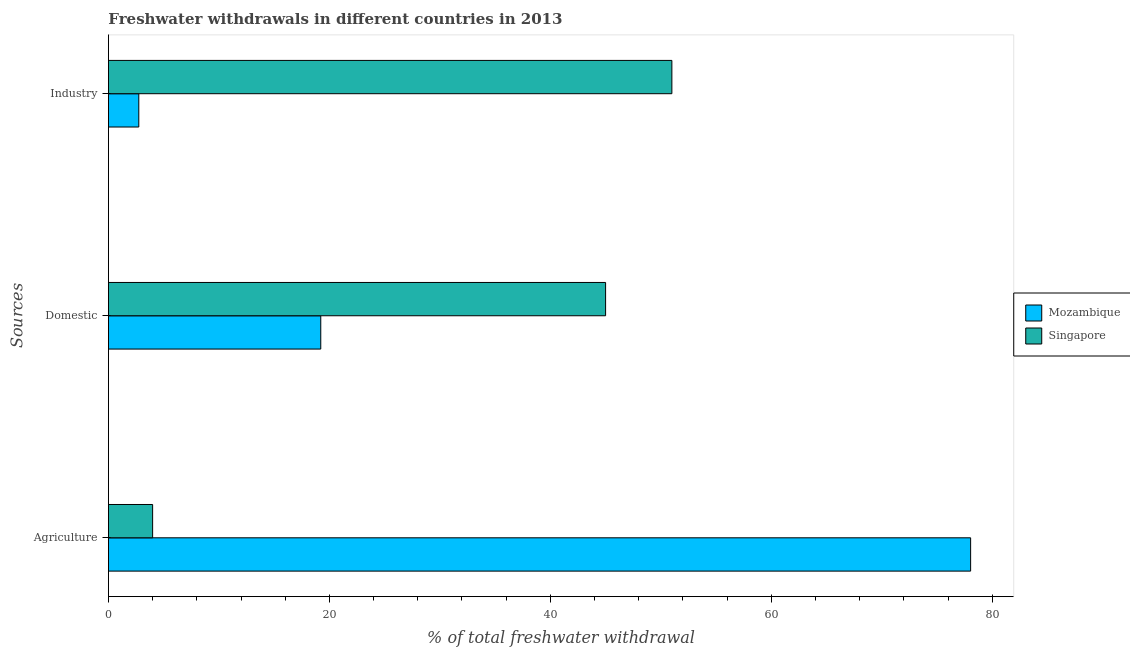How many different coloured bars are there?
Your answer should be very brief. 2. How many groups of bars are there?
Your response must be concise. 3. Are the number of bars per tick equal to the number of legend labels?
Your response must be concise. Yes. Are the number of bars on each tick of the Y-axis equal?
Make the answer very short. Yes. How many bars are there on the 1st tick from the top?
Ensure brevity in your answer.  2. How many bars are there on the 3rd tick from the bottom?
Your answer should be compact. 2. What is the label of the 1st group of bars from the top?
Your response must be concise. Industry. What is the percentage of freshwater withdrawal for agriculture in Mozambique?
Provide a short and direct response. 78.04. Across all countries, what is the maximum percentage of freshwater withdrawal for agriculture?
Offer a terse response. 78.04. In which country was the percentage of freshwater withdrawal for domestic purposes maximum?
Provide a short and direct response. Singapore. In which country was the percentage of freshwater withdrawal for domestic purposes minimum?
Keep it short and to the point. Mozambique. What is the total percentage of freshwater withdrawal for agriculture in the graph?
Your answer should be very brief. 82.04. What is the difference between the percentage of freshwater withdrawal for industry in Singapore and that in Mozambique?
Offer a very short reply. 48.25. What is the difference between the percentage of freshwater withdrawal for agriculture in Singapore and the percentage of freshwater withdrawal for domestic purposes in Mozambique?
Keep it short and to the point. -15.22. What is the average percentage of freshwater withdrawal for industry per country?
Provide a short and direct response. 26.87. What is the difference between the percentage of freshwater withdrawal for agriculture and percentage of freshwater withdrawal for domestic purposes in Singapore?
Give a very brief answer. -41. In how many countries, is the percentage of freshwater withdrawal for industry greater than 16 %?
Make the answer very short. 1. What is the ratio of the percentage of freshwater withdrawal for domestic purposes in Mozambique to that in Singapore?
Make the answer very short. 0.43. Is the percentage of freshwater withdrawal for agriculture in Mozambique less than that in Singapore?
Your answer should be compact. No. What is the difference between the highest and the second highest percentage of freshwater withdrawal for domestic purposes?
Your answer should be compact. 25.78. What is the difference between the highest and the lowest percentage of freshwater withdrawal for industry?
Provide a short and direct response. 48.25. In how many countries, is the percentage of freshwater withdrawal for domestic purposes greater than the average percentage of freshwater withdrawal for domestic purposes taken over all countries?
Your answer should be very brief. 1. What does the 2nd bar from the top in Agriculture represents?
Offer a terse response. Mozambique. What does the 2nd bar from the bottom in Agriculture represents?
Offer a very short reply. Singapore. Is it the case that in every country, the sum of the percentage of freshwater withdrawal for agriculture and percentage of freshwater withdrawal for domestic purposes is greater than the percentage of freshwater withdrawal for industry?
Offer a terse response. No. How many legend labels are there?
Your response must be concise. 2. What is the title of the graph?
Provide a short and direct response. Freshwater withdrawals in different countries in 2013. What is the label or title of the X-axis?
Your response must be concise. % of total freshwater withdrawal. What is the label or title of the Y-axis?
Provide a short and direct response. Sources. What is the % of total freshwater withdrawal of Mozambique in Agriculture?
Make the answer very short. 78.04. What is the % of total freshwater withdrawal of Mozambique in Domestic?
Offer a terse response. 19.22. What is the % of total freshwater withdrawal in Mozambique in Industry?
Your answer should be very brief. 2.75. What is the % of total freshwater withdrawal of Singapore in Industry?
Make the answer very short. 51. Across all Sources, what is the maximum % of total freshwater withdrawal of Mozambique?
Your response must be concise. 78.04. Across all Sources, what is the maximum % of total freshwater withdrawal in Singapore?
Your answer should be very brief. 51. Across all Sources, what is the minimum % of total freshwater withdrawal of Mozambique?
Give a very brief answer. 2.75. Across all Sources, what is the minimum % of total freshwater withdrawal of Singapore?
Give a very brief answer. 4. What is the total % of total freshwater withdrawal of Mozambique in the graph?
Offer a terse response. 100.01. What is the total % of total freshwater withdrawal of Singapore in the graph?
Your answer should be very brief. 100. What is the difference between the % of total freshwater withdrawal in Mozambique in Agriculture and that in Domestic?
Make the answer very short. 58.82. What is the difference between the % of total freshwater withdrawal in Singapore in Agriculture and that in Domestic?
Provide a short and direct response. -41. What is the difference between the % of total freshwater withdrawal in Mozambique in Agriculture and that in Industry?
Give a very brief answer. 75.29. What is the difference between the % of total freshwater withdrawal in Singapore in Agriculture and that in Industry?
Give a very brief answer. -47. What is the difference between the % of total freshwater withdrawal in Mozambique in Domestic and that in Industry?
Keep it short and to the point. 16.47. What is the difference between the % of total freshwater withdrawal in Mozambique in Agriculture and the % of total freshwater withdrawal in Singapore in Domestic?
Provide a short and direct response. 33.04. What is the difference between the % of total freshwater withdrawal in Mozambique in Agriculture and the % of total freshwater withdrawal in Singapore in Industry?
Offer a terse response. 27.04. What is the difference between the % of total freshwater withdrawal in Mozambique in Domestic and the % of total freshwater withdrawal in Singapore in Industry?
Keep it short and to the point. -31.78. What is the average % of total freshwater withdrawal in Mozambique per Sources?
Ensure brevity in your answer.  33.34. What is the average % of total freshwater withdrawal in Singapore per Sources?
Make the answer very short. 33.33. What is the difference between the % of total freshwater withdrawal of Mozambique and % of total freshwater withdrawal of Singapore in Agriculture?
Offer a terse response. 74.04. What is the difference between the % of total freshwater withdrawal in Mozambique and % of total freshwater withdrawal in Singapore in Domestic?
Your answer should be compact. -25.78. What is the difference between the % of total freshwater withdrawal in Mozambique and % of total freshwater withdrawal in Singapore in Industry?
Make the answer very short. -48.25. What is the ratio of the % of total freshwater withdrawal of Mozambique in Agriculture to that in Domestic?
Keep it short and to the point. 4.06. What is the ratio of the % of total freshwater withdrawal in Singapore in Agriculture to that in Domestic?
Provide a succinct answer. 0.09. What is the ratio of the % of total freshwater withdrawal of Mozambique in Agriculture to that in Industry?
Keep it short and to the point. 28.4. What is the ratio of the % of total freshwater withdrawal in Singapore in Agriculture to that in Industry?
Offer a terse response. 0.08. What is the ratio of the % of total freshwater withdrawal in Mozambique in Domestic to that in Industry?
Provide a short and direct response. 6.99. What is the ratio of the % of total freshwater withdrawal in Singapore in Domestic to that in Industry?
Provide a short and direct response. 0.88. What is the difference between the highest and the second highest % of total freshwater withdrawal in Mozambique?
Make the answer very short. 58.82. What is the difference between the highest and the lowest % of total freshwater withdrawal in Mozambique?
Keep it short and to the point. 75.29. What is the difference between the highest and the lowest % of total freshwater withdrawal of Singapore?
Offer a very short reply. 47. 